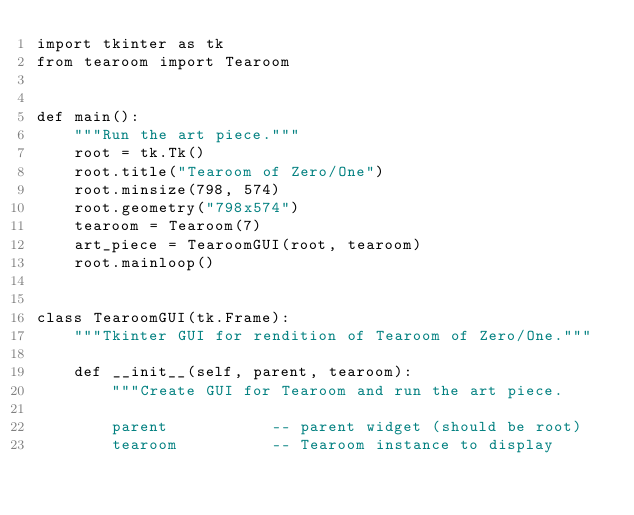Convert code to text. <code><loc_0><loc_0><loc_500><loc_500><_Python_>import tkinter as tk
from tearoom import Tearoom


def main():
    """Run the art piece."""
    root = tk.Tk()
    root.title("Tearoom of Zero/One")
    root.minsize(798, 574)
    root.geometry("798x574")
    tearoom = Tearoom(7)
    art_piece = TearoomGUI(root, tearoom)
    root.mainloop()


class TearoomGUI(tk.Frame):
    """Tkinter GUI for rendition of Tearoom of Zero/One."""

    def __init__(self, parent, tearoom):
        """Create GUI for Tearoom and run the art piece.

        parent           -- parent widget (should be root)
        tearoom          -- Tearoom instance to display</code> 